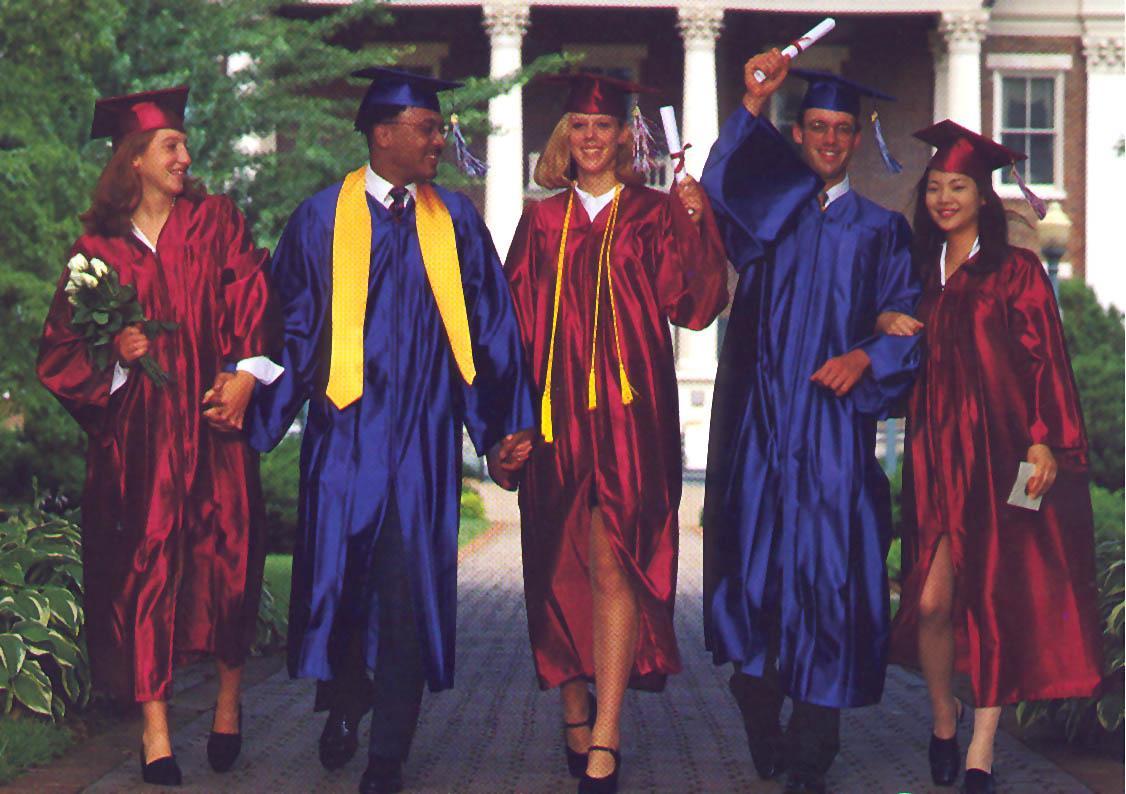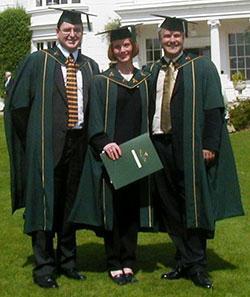The first image is the image on the left, the second image is the image on the right. Analyze the images presented: Is the assertion "There are at least two girls outside in one of the images." valid? Answer yes or no. Yes. The first image is the image on the left, the second image is the image on the right. Assess this claim about the two images: "There are at least two white shirt fronts visible in the image on the right". Correct or not? Answer yes or no. Yes. 